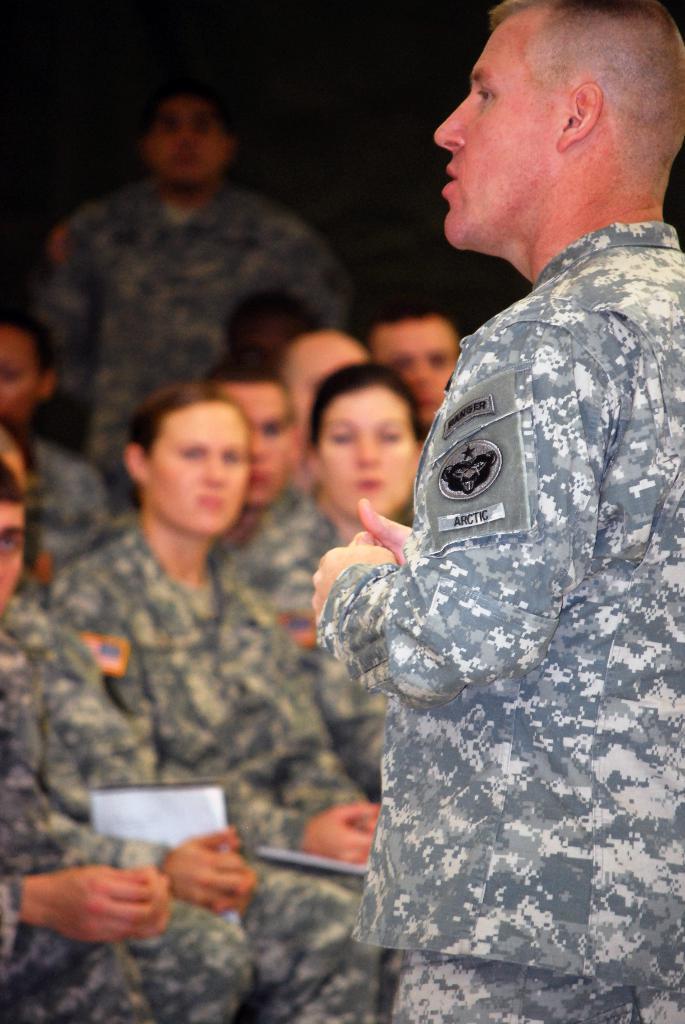Can you describe this image briefly? On the right side of the picture we can see a man is standing, wearing a military uniform. Near to him we can see people sitting. Background is dark and we can see a person is standing. 